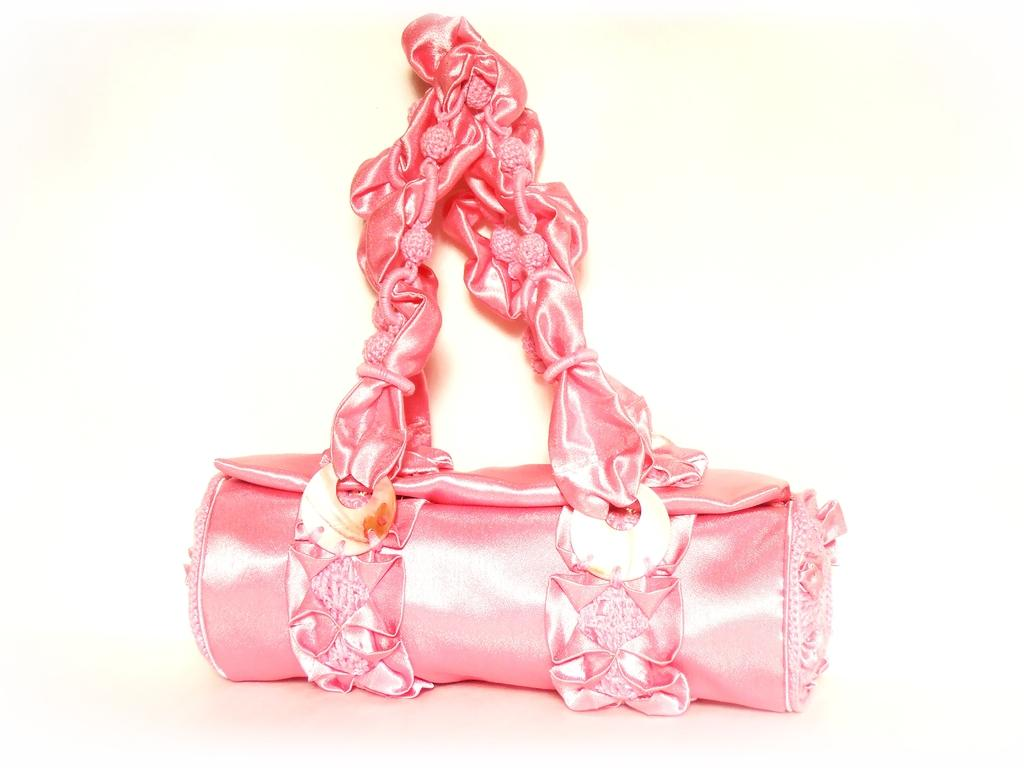What color is the bag in the image? The bag is pink in color. Are there any additional features on the bag? Yes, there are two wooden objects stitched to the bag. What is attached to the handle of the bag? Pink color beads are attached to the handle of the handbag. How many pets are visible in the image? There are no pets visible in the image; it features a pink bag with wooden objects and beads. Is there any dirt on the bag in the image? There is no dirt visible on the bag in the image; it appears clean and well-maintained. 